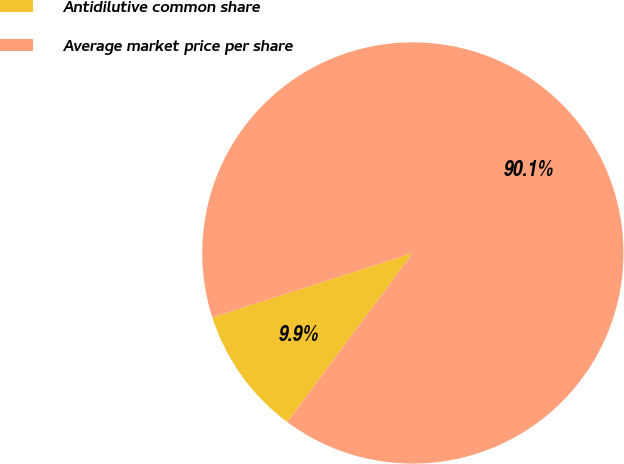Convert chart. <chart><loc_0><loc_0><loc_500><loc_500><pie_chart><fcel>Antidilutive common share<fcel>Average market price per share<nl><fcel>9.87%<fcel>90.13%<nl></chart> 